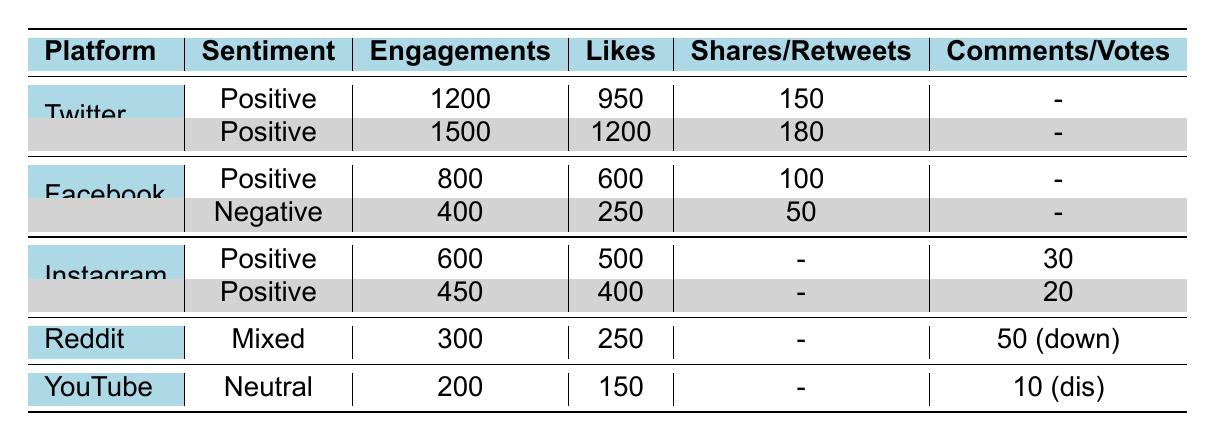What is the total number of engagements across all social media platforms? To calculate the total engagements, I will sum the engagements from each platform: 1200 (Twitter) + 1500 (Twitter) + 800 (Facebook) + 400 (Facebook) + 600 (Instagram) + 450 (Instagram) + 300 (Reddit) + 200 (YouTube) = 5050.
Answer: 5050 Which platform has the highest number of likes? Looking at the likes for each platform, Twitter has 1200 likes (from the second Twitter entry), which is the highest when comparing with all other platforms: 950 (first Twitter) + 600 (Facebook) + 250 (first Facebook) + 500 (Instagram) + 400 (second Instagram) + 250 (Reddit) + 150 (YouTube).
Answer: Twitter Is there a platform where the sentiment is negative? Upon reviewing the sentiment column, yes, Facebook has a negative sentiment for one of its posts.
Answer: Yes What is the overall sentiment trend across the posts on Instagram? All posts from Instagram have a positive sentiment. There are two entries, one with 500 likes and another with 400 likes. Both are affirming support for John.
Answer: Positive How many more engagements does the positive sentiment post on Twitter have compared to the negative sentiment post on Facebook? The positive sentiment post on Twitter has 1500 engagements, while the negative sentiment post on Facebook has 400 engagements. The difference is calculated as 1500 - 400 = 1100.
Answer: 1100 What percentage of total engagements are coming from positive sentiment posts? First, I will sum the engagement of all positive posts which are from Twitter (1200 + 1500), Facebook (800), Instagram (600 + 450), and count negatives and mixed as: 400 (Facebook) + 300 (Reddit) + 200 (YouTube). Total positive engagements = 1200 + 1500 + 800 + 600 + 450 = 3550. Total engagements = 5050. The percentage is (3550 / 5050) * 100 ≈ 70.3%.
Answer: 70.3% Are there any posts with neutral sentiment? Checking the sentiment column, there is one post on YouTube with neutral sentiment.
Answer: Yes What is the average number of engagements for the posts on Facebook? The engagements for Facebook posts are 800 and 400. To find the average, I sum them up (800 + 400 = 1200) and divide by the number of posts (2): Average = 1200/2 = 600.
Answer: 600 Which social media platform shows mixed sentiment? Only Reddit has mixed sentiment for its post as indicated in the sentiment column.
Answer: Reddit 